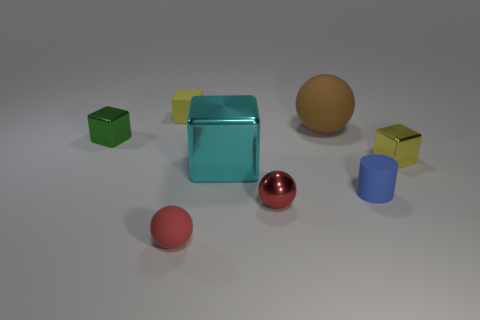Subtract all metal cubes. How many cubes are left? 1 Subtract all purple cubes. How many red spheres are left? 2 Subtract all brown spheres. How many spheres are left? 2 Subtract 2 blocks. How many blocks are left? 2 Subtract all cylinders. How many objects are left? 7 Add 2 large blue shiny cubes. How many objects exist? 10 Subtract all green cylinders. Subtract all purple blocks. How many cylinders are left? 1 Subtract all tiny brown metallic things. Subtract all small metal spheres. How many objects are left? 7 Add 1 rubber objects. How many rubber objects are left? 5 Add 8 tiny purple objects. How many tiny purple objects exist? 8 